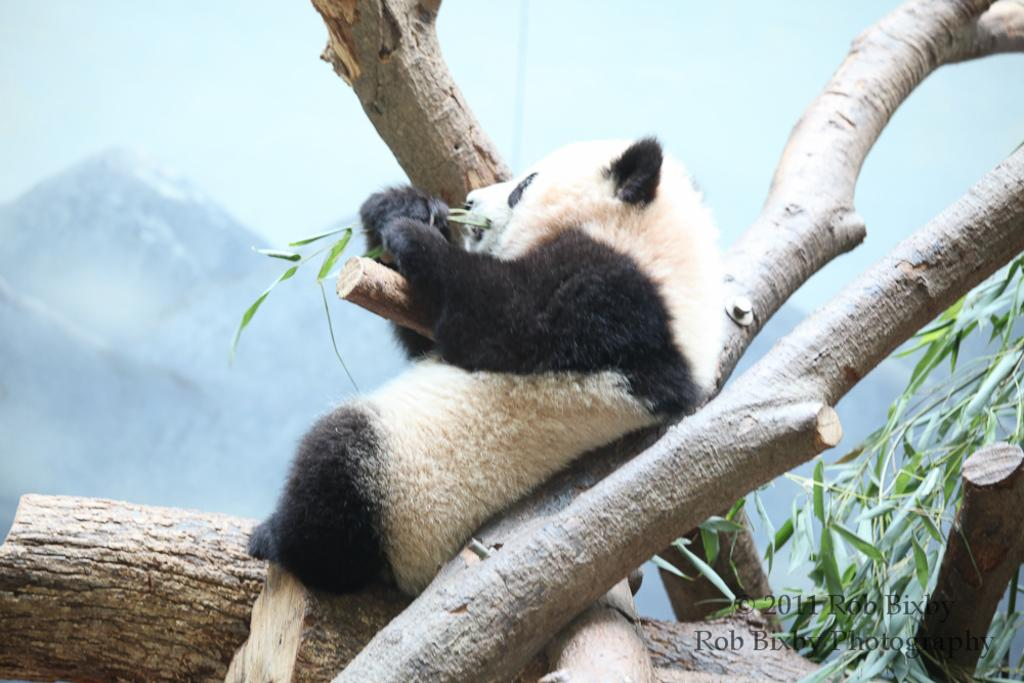What animal is in the center of the image? There is a panda in the center of the image. What is located at the bottom of the image? There is a tree at the bottom of the image. What type of landscape can be seen in the background of the image? Mountains are visible in the background of the image. What type of humor can be seen in the image? There is no humor present in the image; it features a panda and a tree with mountains in the background. 